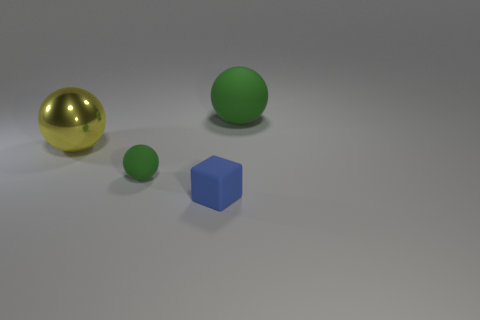How many small rubber objects have the same color as the big metal sphere? In the image, there are two small green rubber spheres which share the same color attribute, that of being green. However, the big sphere is golden and not green, thus there are no small rubber objects sharing the same color as the big metal sphere. So the answer is none. 